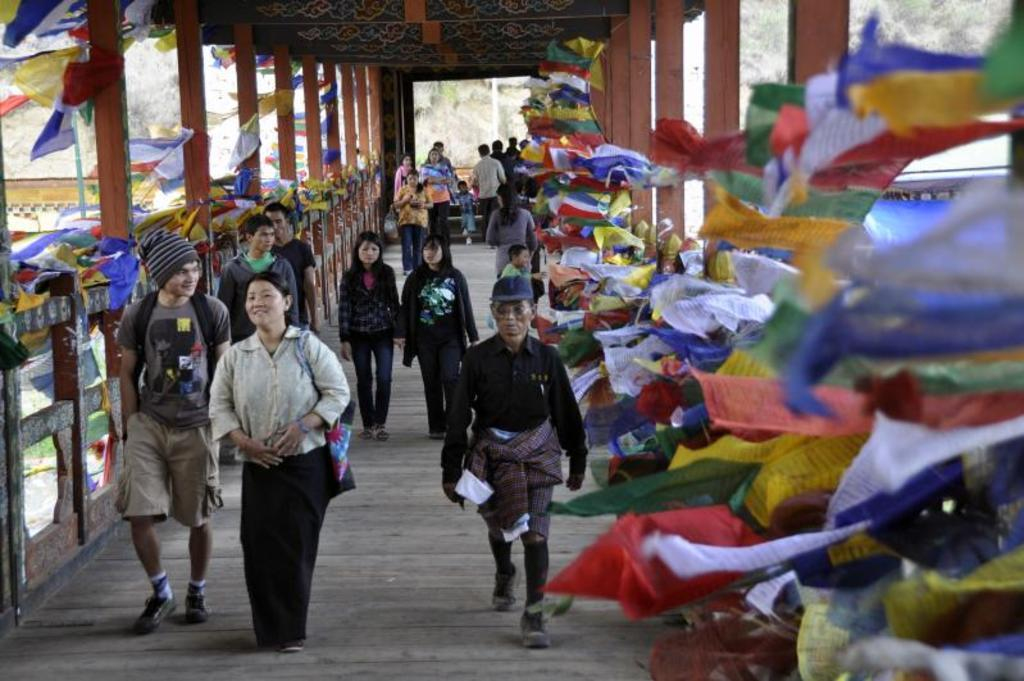What are the people in the image doing? The people in the image are walking. What architectural features can be seen on both sides of the image? There are pillars on both the right and left sides of the image. What can be seen hanging or draped in the image? Clothes are visible in the image. What type of natural scenery is visible in the background of the image? There are trees in the background of the image. What type of disgust can be seen on the faces of the people in the image? There is no indication of disgust on the faces of the people in the image; they are simply walking. What type of produce is being harvested in the image? There is no produce or harvesting activity present in the image. 